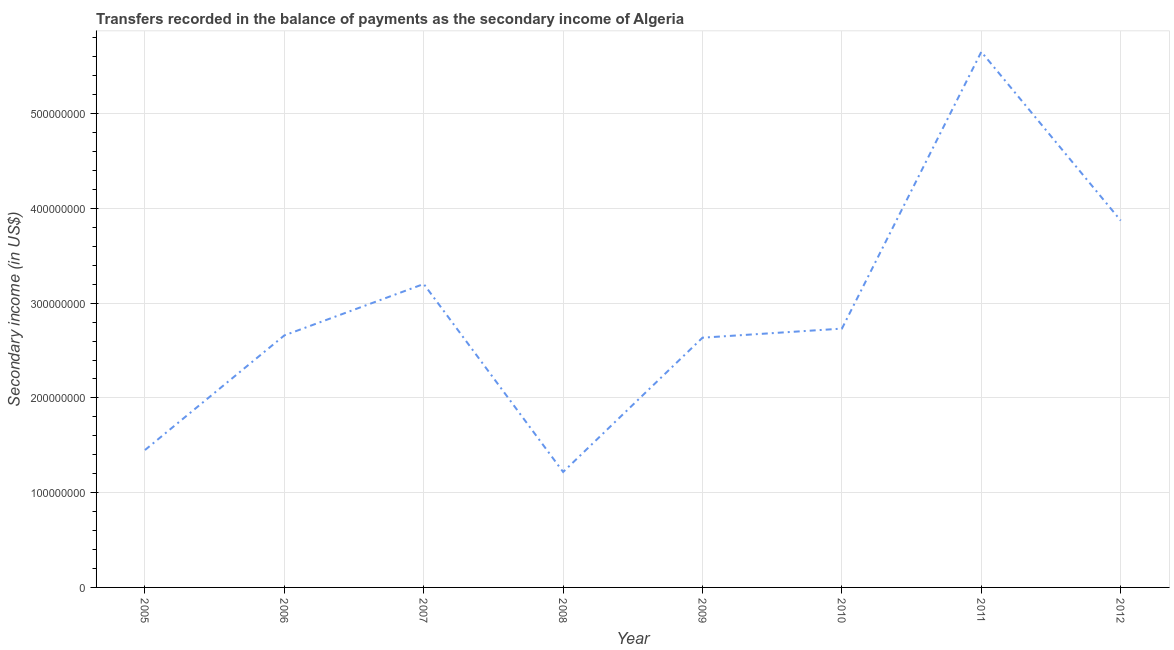What is the amount of secondary income in 2009?
Keep it short and to the point. 2.64e+08. Across all years, what is the maximum amount of secondary income?
Provide a short and direct response. 5.65e+08. Across all years, what is the minimum amount of secondary income?
Make the answer very short. 1.22e+08. What is the sum of the amount of secondary income?
Provide a succinct answer. 2.34e+09. What is the difference between the amount of secondary income in 2007 and 2011?
Provide a short and direct response. -2.45e+08. What is the average amount of secondary income per year?
Offer a very short reply. 2.93e+08. What is the median amount of secondary income?
Your response must be concise. 2.70e+08. In how many years, is the amount of secondary income greater than 500000000 US$?
Provide a short and direct response. 1. What is the ratio of the amount of secondary income in 2007 to that in 2008?
Keep it short and to the point. 2.63. Is the amount of secondary income in 2007 less than that in 2011?
Provide a succinct answer. Yes. Is the difference between the amount of secondary income in 2007 and 2010 greater than the difference between any two years?
Offer a terse response. No. What is the difference between the highest and the second highest amount of secondary income?
Keep it short and to the point. 1.78e+08. Is the sum of the amount of secondary income in 2010 and 2012 greater than the maximum amount of secondary income across all years?
Your answer should be compact. Yes. What is the difference between the highest and the lowest amount of secondary income?
Keep it short and to the point. 4.43e+08. What is the difference between two consecutive major ticks on the Y-axis?
Provide a short and direct response. 1.00e+08. Does the graph contain any zero values?
Offer a very short reply. No. What is the title of the graph?
Offer a terse response. Transfers recorded in the balance of payments as the secondary income of Algeria. What is the label or title of the X-axis?
Your answer should be compact. Year. What is the label or title of the Y-axis?
Keep it short and to the point. Secondary income (in US$). What is the Secondary income (in US$) of 2005?
Your response must be concise. 1.45e+08. What is the Secondary income (in US$) in 2006?
Provide a short and direct response. 2.66e+08. What is the Secondary income (in US$) of 2007?
Give a very brief answer. 3.20e+08. What is the Secondary income (in US$) of 2008?
Ensure brevity in your answer.  1.22e+08. What is the Secondary income (in US$) of 2009?
Make the answer very short. 2.64e+08. What is the Secondary income (in US$) in 2010?
Your response must be concise. 2.73e+08. What is the Secondary income (in US$) in 2011?
Provide a short and direct response. 5.65e+08. What is the Secondary income (in US$) of 2012?
Give a very brief answer. 3.87e+08. What is the difference between the Secondary income (in US$) in 2005 and 2006?
Give a very brief answer. -1.21e+08. What is the difference between the Secondary income (in US$) in 2005 and 2007?
Offer a very short reply. -1.75e+08. What is the difference between the Secondary income (in US$) in 2005 and 2008?
Offer a terse response. 2.31e+07. What is the difference between the Secondary income (in US$) in 2005 and 2009?
Provide a succinct answer. -1.19e+08. What is the difference between the Secondary income (in US$) in 2005 and 2010?
Ensure brevity in your answer.  -1.28e+08. What is the difference between the Secondary income (in US$) in 2005 and 2011?
Your answer should be compact. -4.20e+08. What is the difference between the Secondary income (in US$) in 2005 and 2012?
Your answer should be very brief. -2.42e+08. What is the difference between the Secondary income (in US$) in 2006 and 2007?
Provide a succinct answer. -5.42e+07. What is the difference between the Secondary income (in US$) in 2006 and 2008?
Offer a terse response. 1.44e+08. What is the difference between the Secondary income (in US$) in 2006 and 2009?
Your answer should be very brief. 2.41e+06. What is the difference between the Secondary income (in US$) in 2006 and 2010?
Offer a terse response. -7.16e+06. What is the difference between the Secondary income (in US$) in 2006 and 2011?
Your answer should be very brief. -2.99e+08. What is the difference between the Secondary income (in US$) in 2006 and 2012?
Provide a succinct answer. -1.21e+08. What is the difference between the Secondary income (in US$) in 2007 and 2008?
Provide a short and direct response. 1.98e+08. What is the difference between the Secondary income (in US$) in 2007 and 2009?
Ensure brevity in your answer.  5.67e+07. What is the difference between the Secondary income (in US$) in 2007 and 2010?
Your answer should be compact. 4.71e+07. What is the difference between the Secondary income (in US$) in 2007 and 2011?
Ensure brevity in your answer.  -2.45e+08. What is the difference between the Secondary income (in US$) in 2007 and 2012?
Provide a succinct answer. -6.69e+07. What is the difference between the Secondary income (in US$) in 2008 and 2009?
Your response must be concise. -1.42e+08. What is the difference between the Secondary income (in US$) in 2008 and 2010?
Keep it short and to the point. -1.51e+08. What is the difference between the Secondary income (in US$) in 2008 and 2011?
Your answer should be compact. -4.43e+08. What is the difference between the Secondary income (in US$) in 2008 and 2012?
Your response must be concise. -2.65e+08. What is the difference between the Secondary income (in US$) in 2009 and 2010?
Ensure brevity in your answer.  -9.57e+06. What is the difference between the Secondary income (in US$) in 2009 and 2011?
Offer a terse response. -3.02e+08. What is the difference between the Secondary income (in US$) in 2009 and 2012?
Offer a very short reply. -1.24e+08. What is the difference between the Secondary income (in US$) in 2010 and 2011?
Offer a terse response. -2.92e+08. What is the difference between the Secondary income (in US$) in 2010 and 2012?
Make the answer very short. -1.14e+08. What is the difference between the Secondary income (in US$) in 2011 and 2012?
Ensure brevity in your answer.  1.78e+08. What is the ratio of the Secondary income (in US$) in 2005 to that in 2006?
Make the answer very short. 0.55. What is the ratio of the Secondary income (in US$) in 2005 to that in 2007?
Provide a succinct answer. 0.45. What is the ratio of the Secondary income (in US$) in 2005 to that in 2008?
Offer a terse response. 1.19. What is the ratio of the Secondary income (in US$) in 2005 to that in 2009?
Offer a terse response. 0.55. What is the ratio of the Secondary income (in US$) in 2005 to that in 2010?
Provide a short and direct response. 0.53. What is the ratio of the Secondary income (in US$) in 2005 to that in 2011?
Make the answer very short. 0.26. What is the ratio of the Secondary income (in US$) in 2005 to that in 2012?
Your response must be concise. 0.37. What is the ratio of the Secondary income (in US$) in 2006 to that in 2007?
Give a very brief answer. 0.83. What is the ratio of the Secondary income (in US$) in 2006 to that in 2008?
Provide a succinct answer. 2.18. What is the ratio of the Secondary income (in US$) in 2006 to that in 2010?
Your response must be concise. 0.97. What is the ratio of the Secondary income (in US$) in 2006 to that in 2011?
Offer a terse response. 0.47. What is the ratio of the Secondary income (in US$) in 2006 to that in 2012?
Offer a terse response. 0.69. What is the ratio of the Secondary income (in US$) in 2007 to that in 2008?
Give a very brief answer. 2.63. What is the ratio of the Secondary income (in US$) in 2007 to that in 2009?
Provide a short and direct response. 1.22. What is the ratio of the Secondary income (in US$) in 2007 to that in 2010?
Offer a very short reply. 1.17. What is the ratio of the Secondary income (in US$) in 2007 to that in 2011?
Offer a terse response. 0.57. What is the ratio of the Secondary income (in US$) in 2007 to that in 2012?
Offer a very short reply. 0.83. What is the ratio of the Secondary income (in US$) in 2008 to that in 2009?
Offer a very short reply. 0.46. What is the ratio of the Secondary income (in US$) in 2008 to that in 2010?
Provide a short and direct response. 0.45. What is the ratio of the Secondary income (in US$) in 2008 to that in 2011?
Keep it short and to the point. 0.22. What is the ratio of the Secondary income (in US$) in 2008 to that in 2012?
Provide a short and direct response. 0.32. What is the ratio of the Secondary income (in US$) in 2009 to that in 2011?
Keep it short and to the point. 0.47. What is the ratio of the Secondary income (in US$) in 2009 to that in 2012?
Provide a succinct answer. 0.68. What is the ratio of the Secondary income (in US$) in 2010 to that in 2011?
Your answer should be compact. 0.48. What is the ratio of the Secondary income (in US$) in 2010 to that in 2012?
Give a very brief answer. 0.7. What is the ratio of the Secondary income (in US$) in 2011 to that in 2012?
Your response must be concise. 1.46. 